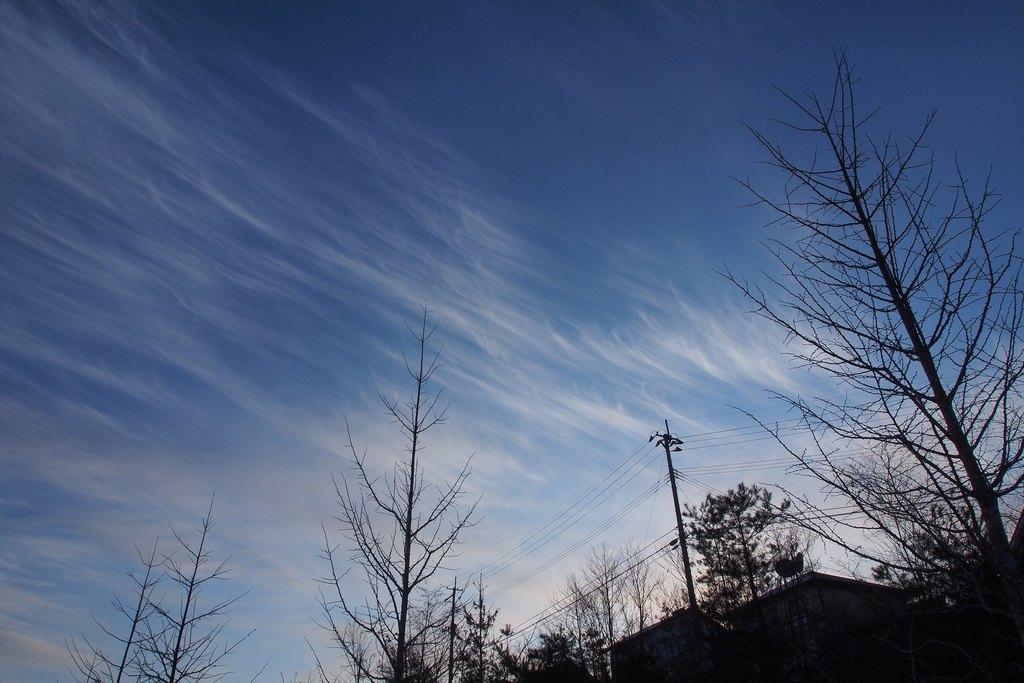How would you summarize this image in a sentence or two? At the bottom of the image there are trees and we can see a pole. There are wires. In the background there is sky. 